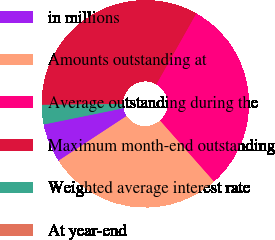Convert chart. <chart><loc_0><loc_0><loc_500><loc_500><pie_chart><fcel>in millions<fcel>Amounts outstanding at<fcel>Average outstanding during the<fcel>Maximum month-end outstanding<fcel>Weighted average interest rate<fcel>At year-end<nl><fcel>6.05%<fcel>27.28%<fcel>30.31%<fcel>33.33%<fcel>3.03%<fcel>0.0%<nl></chart> 